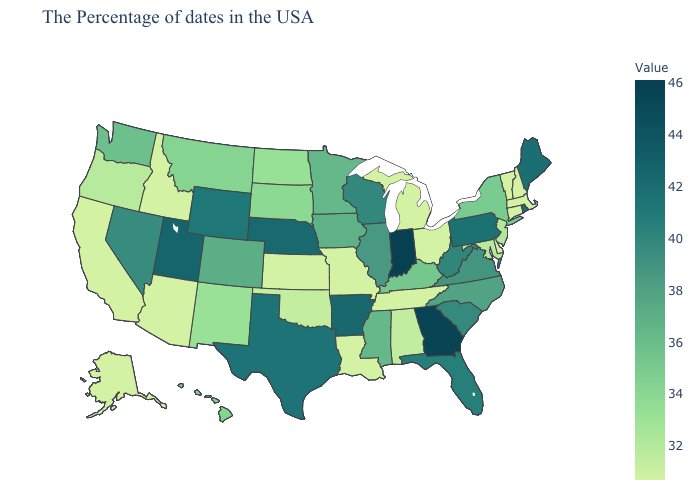Which states have the lowest value in the Northeast?
Give a very brief answer. Massachusetts, New Hampshire, Vermont, Connecticut. Does Pennsylvania have the lowest value in the USA?
Write a very short answer. No. Which states have the highest value in the USA?
Give a very brief answer. Indiana. Among the states that border Rhode Island , which have the highest value?
Be succinct. Massachusetts, Connecticut. Is the legend a continuous bar?
Short answer required. Yes. 